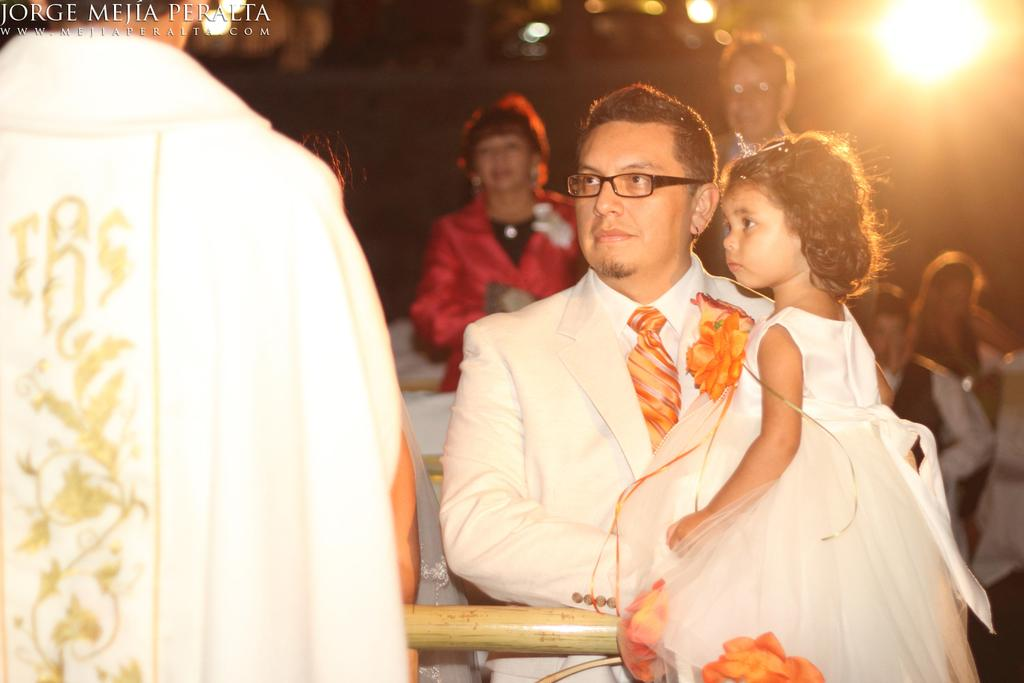Who is in the image? People are present in the image. Can you describe the interaction between the people? A person is holding a girl. What is the girl wearing? The girl is wearing a suit and an orange tie. What can be seen in the background of the image? There is a light at the back of the image. What letter is the girl holding in the image? There is no letter present in the image; the girl is wearing a suit and an orange tie. Where is the desk located in the image? There is no desk present in the image. 